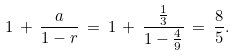Convert formula to latex. <formula><loc_0><loc_0><loc_500><loc_500>1 \, + \, { \frac { a } { 1 - r } } \, = \, 1 \, + \, { \frac { \frac { 1 } { 3 } } { 1 - { \frac { 4 } { 9 } } } } \, = \, { \frac { 8 } { 5 } } .</formula> 